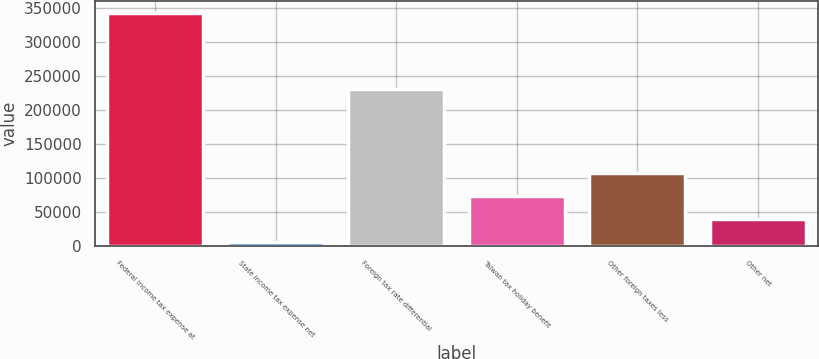Convert chart. <chart><loc_0><loc_0><loc_500><loc_500><bar_chart><fcel>Federal income tax expense at<fcel>State income tax expense net<fcel>Foreign tax rate differential<fcel>Taiwan tax holiday benefit<fcel>Other foreign taxes less<fcel>Other net<nl><fcel>342396<fcel>5922<fcel>230243<fcel>73216.8<fcel>106864<fcel>39569.4<nl></chart> 